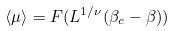<formula> <loc_0><loc_0><loc_500><loc_500>\langle \mu \rangle = F ( L ^ { 1 / \nu } ( \beta _ { c } - \beta ) )</formula> 